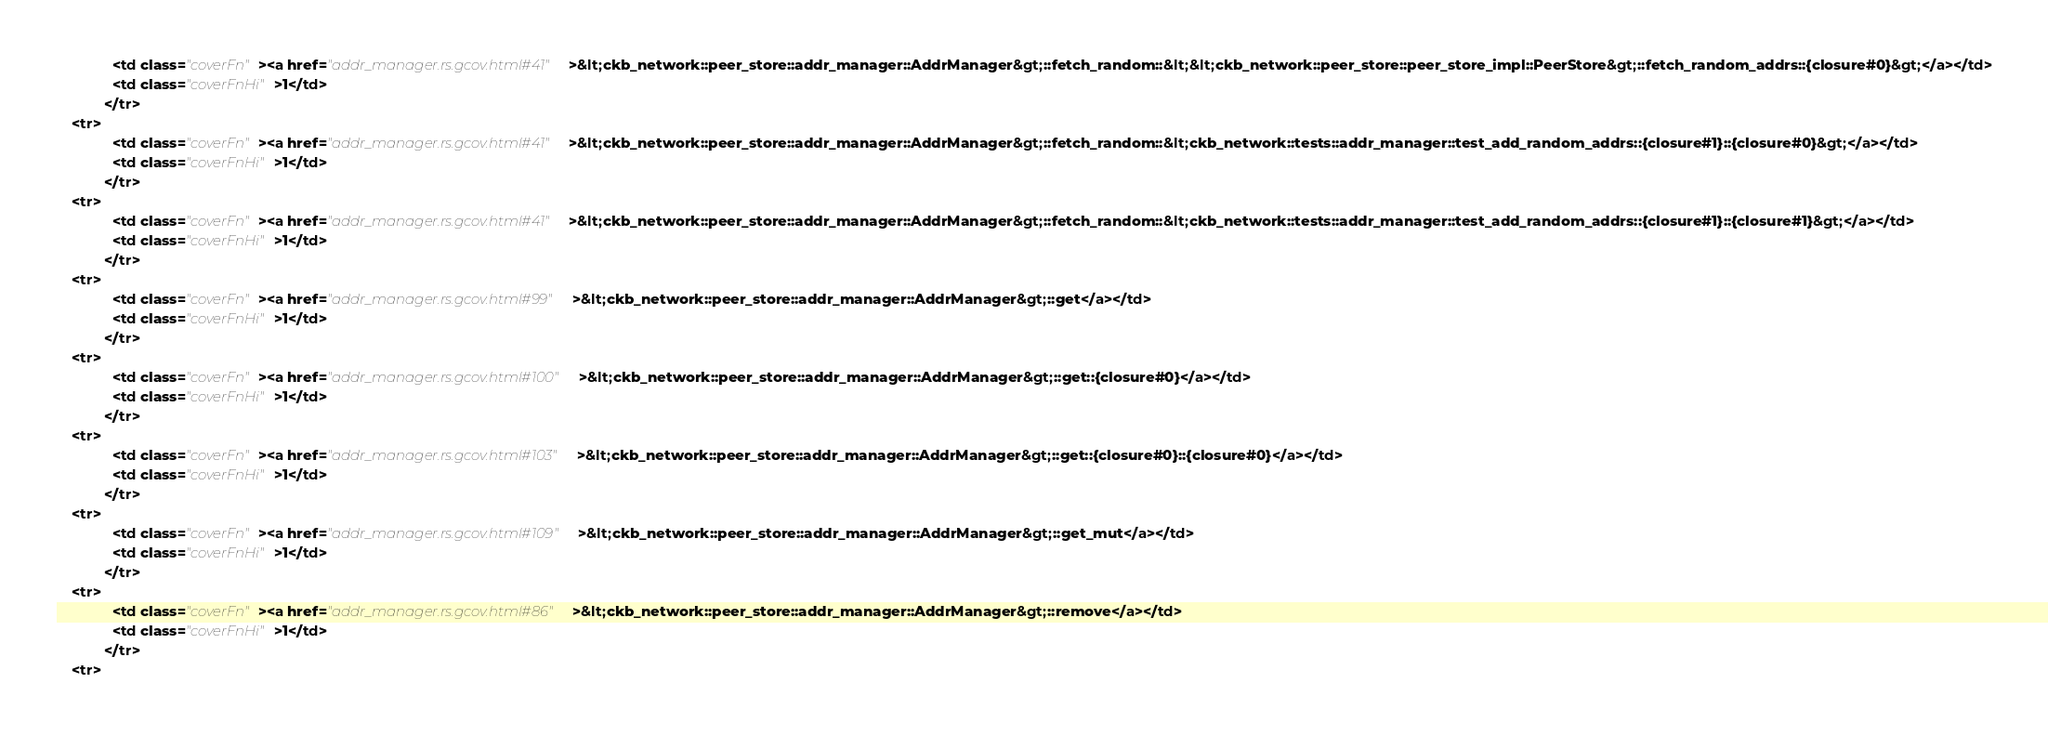<code> <loc_0><loc_0><loc_500><loc_500><_HTML_>              <td class="coverFn"><a href="addr_manager.rs.gcov.html#41">&lt;ckb_network::peer_store::addr_manager::AddrManager&gt;::fetch_random::&lt;&lt;ckb_network::peer_store::peer_store_impl::PeerStore&gt;::fetch_random_addrs::{closure#0}&gt;</a></td>
              <td class="coverFnHi">1</td>
            </tr>
    <tr>
              <td class="coverFn"><a href="addr_manager.rs.gcov.html#41">&lt;ckb_network::peer_store::addr_manager::AddrManager&gt;::fetch_random::&lt;ckb_network::tests::addr_manager::test_add_random_addrs::{closure#1}::{closure#0}&gt;</a></td>
              <td class="coverFnHi">1</td>
            </tr>
    <tr>
              <td class="coverFn"><a href="addr_manager.rs.gcov.html#41">&lt;ckb_network::peer_store::addr_manager::AddrManager&gt;::fetch_random::&lt;ckb_network::tests::addr_manager::test_add_random_addrs::{closure#1}::{closure#1}&gt;</a></td>
              <td class="coverFnHi">1</td>
            </tr>
    <tr>
              <td class="coverFn"><a href="addr_manager.rs.gcov.html#99">&lt;ckb_network::peer_store::addr_manager::AddrManager&gt;::get</a></td>
              <td class="coverFnHi">1</td>
            </tr>
    <tr>
              <td class="coverFn"><a href="addr_manager.rs.gcov.html#100">&lt;ckb_network::peer_store::addr_manager::AddrManager&gt;::get::{closure#0}</a></td>
              <td class="coverFnHi">1</td>
            </tr>
    <tr>
              <td class="coverFn"><a href="addr_manager.rs.gcov.html#103">&lt;ckb_network::peer_store::addr_manager::AddrManager&gt;::get::{closure#0}::{closure#0}</a></td>
              <td class="coverFnHi">1</td>
            </tr>
    <tr>
              <td class="coverFn"><a href="addr_manager.rs.gcov.html#109">&lt;ckb_network::peer_store::addr_manager::AddrManager&gt;::get_mut</a></td>
              <td class="coverFnHi">1</td>
            </tr>
    <tr>
              <td class="coverFn"><a href="addr_manager.rs.gcov.html#86">&lt;ckb_network::peer_store::addr_manager::AddrManager&gt;::remove</a></td>
              <td class="coverFnHi">1</td>
            </tr>
    <tr></code> 